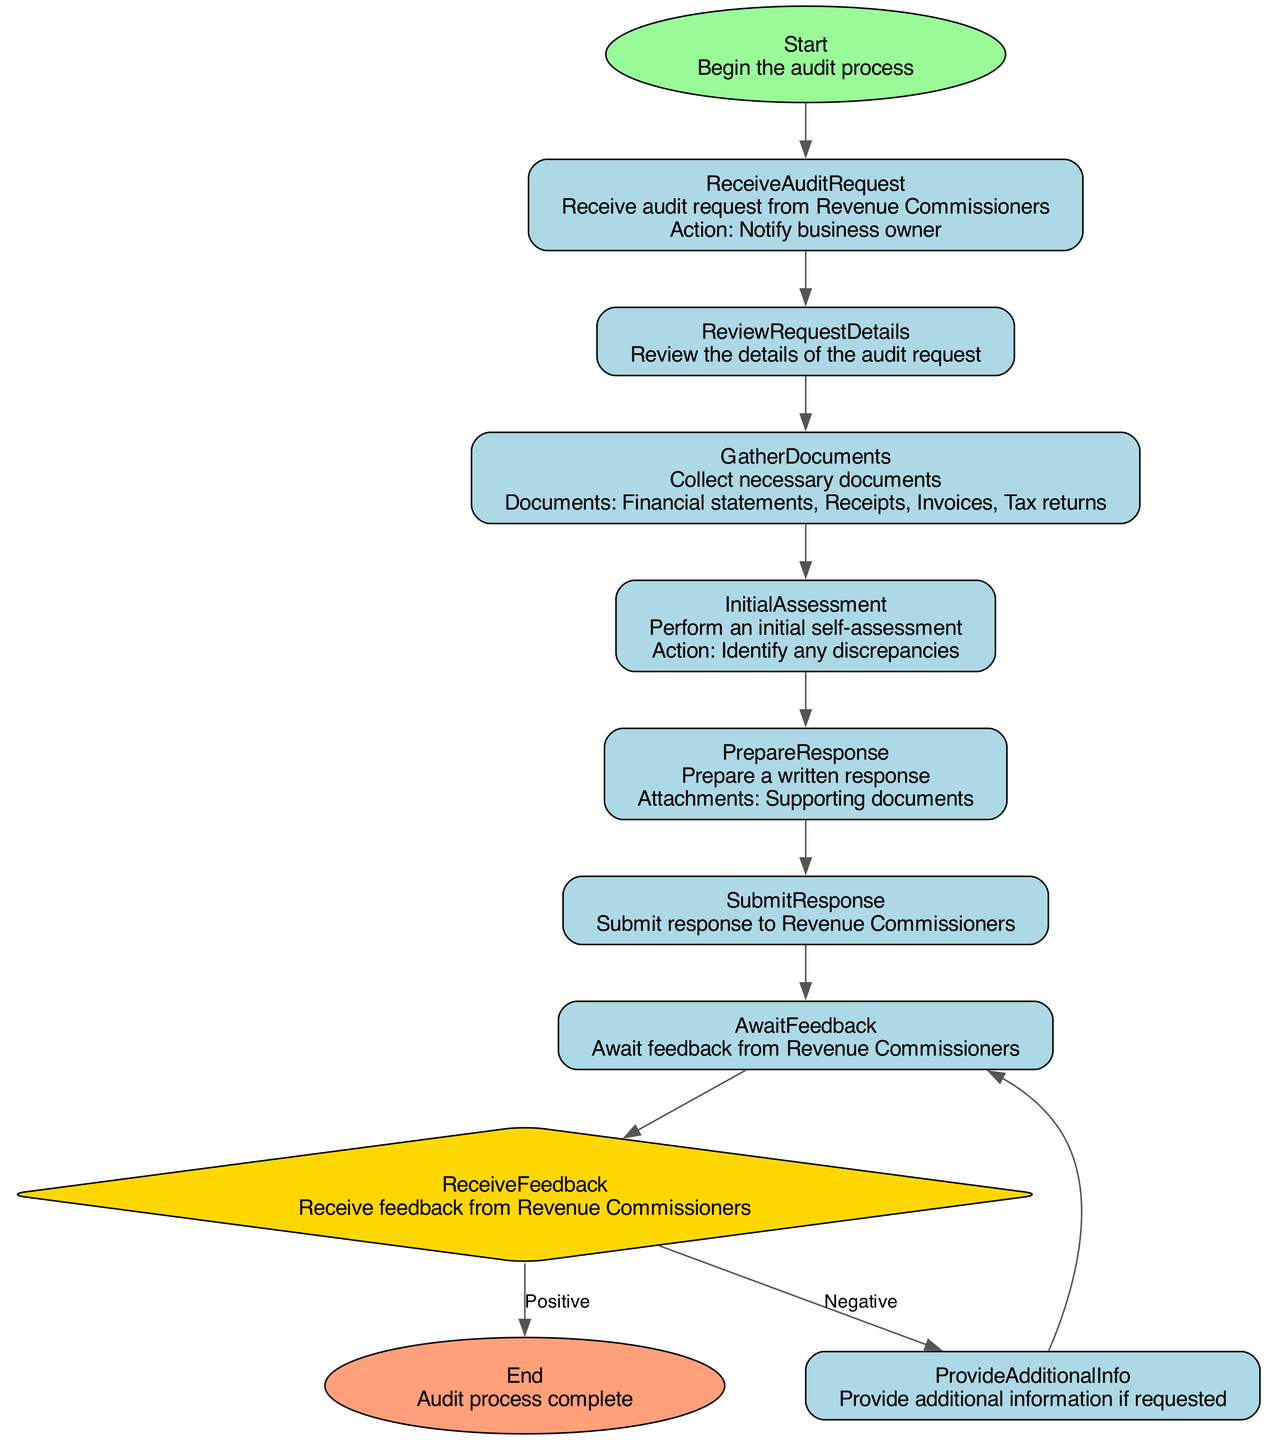What is the first step in the audit process? The first step is labeled "Start," which states to "Begin the audit process." Therefore, the first step in the process is to start.
Answer: Start How many documents are collected in the "GatherDocuments" step? In the "GatherDocuments" step, the necessary documents listed are four: financial statements, receipts, invoices, and tax returns. Thus, the number of documents is four.
Answer: 4 What action is taken after receiving feedback if it is negative? The "ReceiveFeedback" node shows two possible actions based on feedback. If the feedback is negative, the action is "Request further information/clarification." Thus, the action taken is to request further information.
Answer: Request further information What are the two possible outcomes of the "ReceiveFeedback" step? In the "ReceiveFeedback" step, there are two labeled actions based on feedback: positive leads to closing the audit, and negative leads to requesting further information. Therefore, the two outcomes are close audit and request further information.
Answer: Close audit, request further information What do you do after the "SubmitResponse" step? After the "SubmitResponse" step, the process moves to the "AwaitFeedback" step, where the business awaits feedback from Revenue Commissioners. Thus, the next step is to await feedback.
Answer: Await feedback What happens if the audit request details are reviewed? Once the "ReviewRequestDetails" step is completed, the next step is to "GatherDocuments," which indicates that document collection is the immediate next action following the review. Therefore, after reviewing request details, documents are gathered.
Answer: Gather documents How is the final step represented in the flowchart? The final step is represented as "End," which indicates that the audit process is complete. In the flowchart, the end is depicted as an ellipse filled with a different color for clarity. Thus, the final step is completed.
Answer: End How many edges are drawn from the "ReceiveFeedback" node? The "ReceiveFeedback" node has two edges departing from it; one leads to the "ProvideAdditionalInfo" step for negative feedback, and the other leads to the "End" step for positive feedback. Therefore, there are two edges drawn from this node.
Answer: 2 What is the primary action during the "InitialAssessment"? In the "InitialAssessment" step, the action is to "Identify any discrepancies," indicating that the focus during this step is on identifying discrepancies within the audit materials. Thus, the primary action is identifying discrepancies.
Answer: Identify any discrepancies 